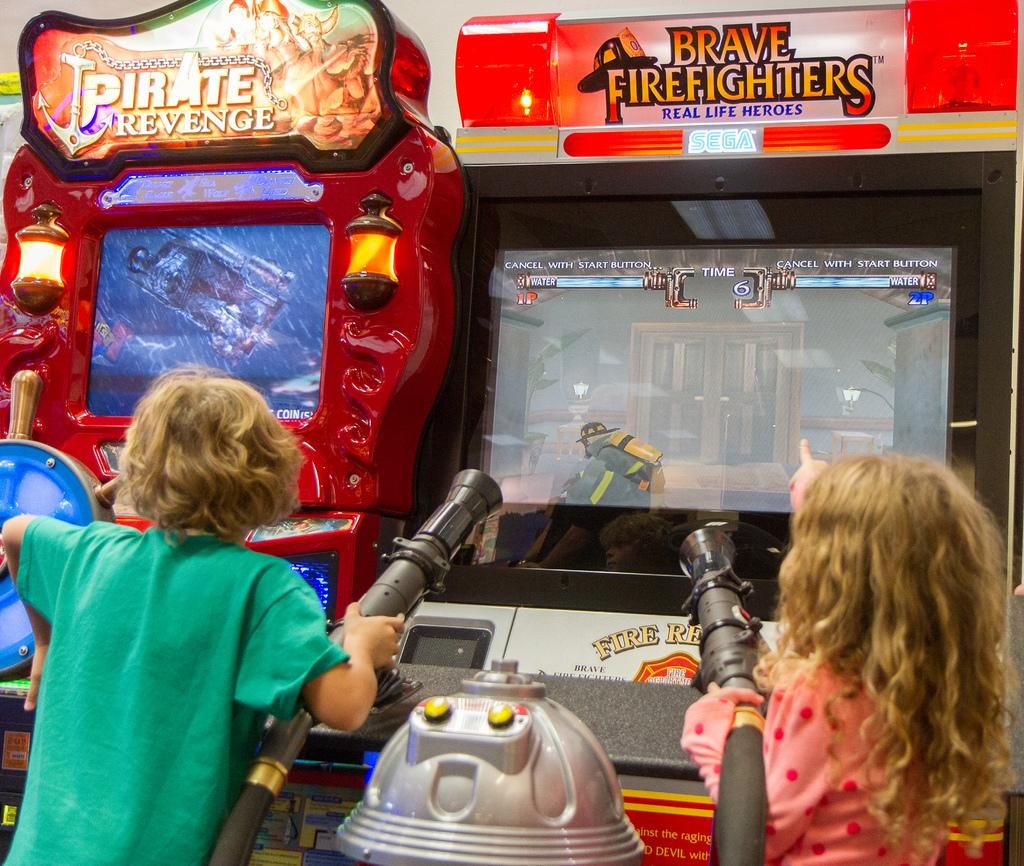How many kids are in the image? There are two kids in the image. What are the kids doing in the image? The kids are standing and holding pipes. What is in front of the kids? There are game machines in front of the kids. Can you tell me how many deer are visible in the image? There are no deer present in the image; it features two kids holding pipes and game machines in front of them. 